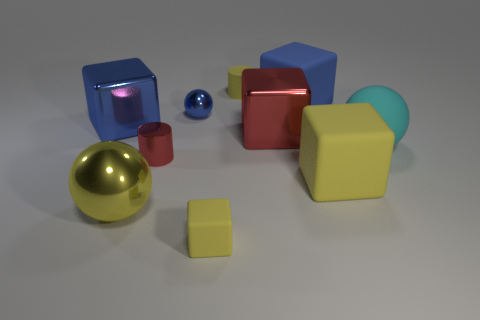Subtract all red cubes. How many cubes are left? 4 Subtract all large red metal blocks. How many blocks are left? 4 Subtract 2 blue cubes. How many objects are left? 8 Subtract all spheres. How many objects are left? 7 Subtract 2 cylinders. How many cylinders are left? 0 Subtract all green cylinders. Subtract all purple cubes. How many cylinders are left? 2 Subtract all gray balls. How many red cubes are left? 1 Subtract all small rubber things. Subtract all red objects. How many objects are left? 6 Add 2 small blue objects. How many small blue objects are left? 3 Add 3 small red objects. How many small red objects exist? 4 